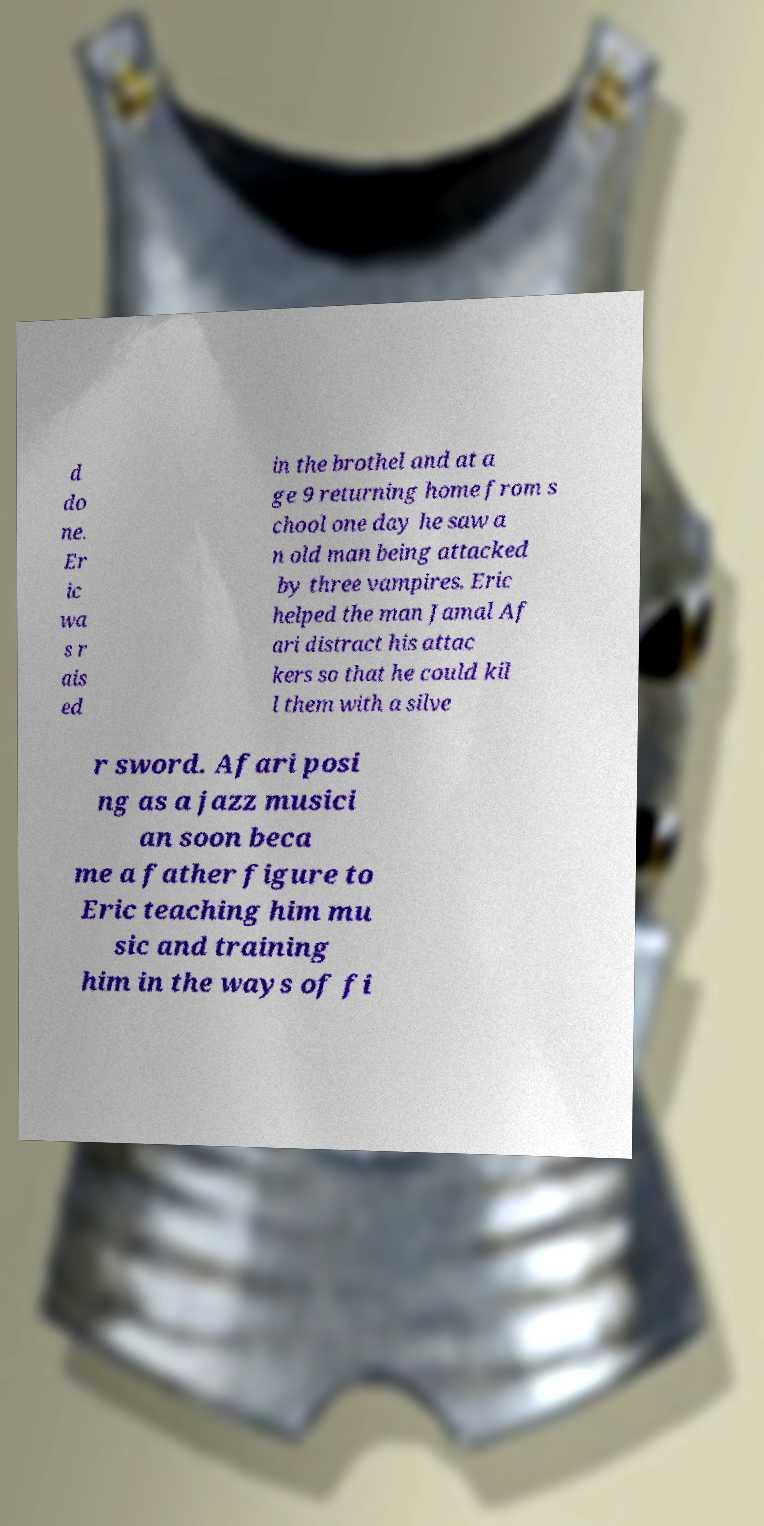What messages or text are displayed in this image? I need them in a readable, typed format. d do ne. Er ic wa s r ais ed in the brothel and at a ge 9 returning home from s chool one day he saw a n old man being attacked by three vampires. Eric helped the man Jamal Af ari distract his attac kers so that he could kil l them with a silve r sword. Afari posi ng as a jazz musici an soon beca me a father figure to Eric teaching him mu sic and training him in the ways of fi 